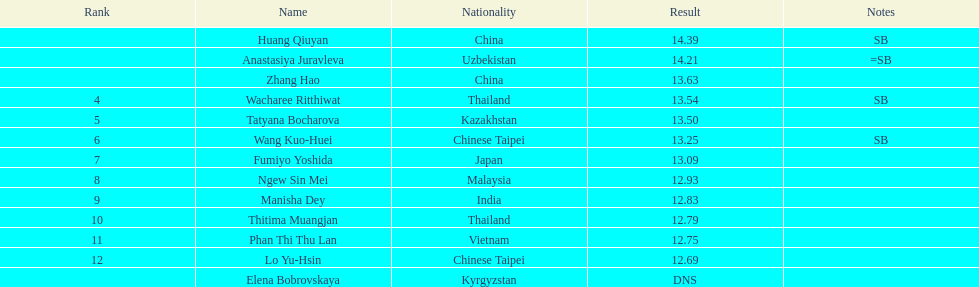What was the number of competitors with less than 1 6. Write the full table. {'header': ['Rank', 'Name', 'Nationality', 'Result', 'Notes'], 'rows': [['', 'Huang Qiuyan', 'China', '14.39', 'SB'], ['', 'Anastasiya Juravleva', 'Uzbekistan', '14.21', '=SB'], ['', 'Zhang Hao', 'China', '13.63', ''], ['4', 'Wacharee Ritthiwat', 'Thailand', '13.54', 'SB'], ['5', 'Tatyana Bocharova', 'Kazakhstan', '13.50', ''], ['6', 'Wang Kuo-Huei', 'Chinese Taipei', '13.25', 'SB'], ['7', 'Fumiyo Yoshida', 'Japan', '13.09', ''], ['8', 'Ngew Sin Mei', 'Malaysia', '12.93', ''], ['9', 'Manisha Dey', 'India', '12.83', ''], ['10', 'Thitima Muangjan', 'Thailand', '12.79', ''], ['11', 'Phan Thi Thu Lan', 'Vietnam', '12.75', ''], ['12', 'Lo Yu-Hsin', 'Chinese Taipei', '12.69', ''], ['', 'Elena Bobrovskaya', 'Kyrgyzstan', 'DNS', '']]} 